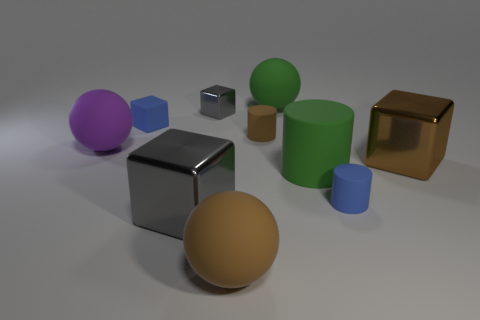Does the large cylinder have the same color as the ball to the right of the small brown cylinder?
Offer a terse response. Yes. What number of things are either small cyan matte balls or cubes?
Your answer should be very brief. 4. Are there any other things that have the same color as the matte block?
Make the answer very short. Yes. Are the large cylinder and the tiny object that is right of the small brown cylinder made of the same material?
Ensure brevity in your answer.  Yes. The brown thing that is in front of the big brown object behind the brown matte ball is what shape?
Keep it short and to the point. Sphere. There is a matte thing that is in front of the tiny brown object and left of the tiny gray cube; what shape is it?
Provide a succinct answer. Sphere. What number of objects are either large purple rubber things or rubber balls that are in front of the small gray metal cube?
Offer a terse response. 2. There is a large brown object that is the same shape as the purple rubber object; what material is it?
Keep it short and to the point. Rubber. Is there anything else that has the same material as the blue cylinder?
Make the answer very short. Yes. What is the material of the large object that is in front of the rubber cube and behind the brown cube?
Make the answer very short. Rubber. 